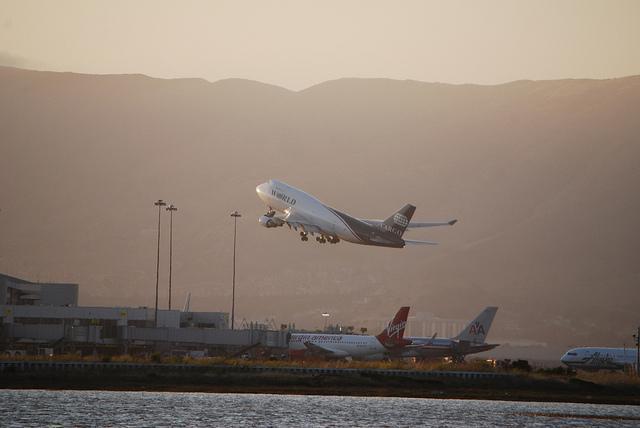How many airplanes are there?
Give a very brief answer. 2. 